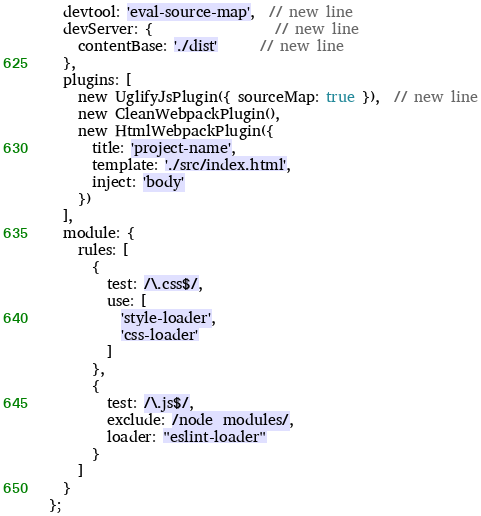<code> <loc_0><loc_0><loc_500><loc_500><_JavaScript_>  devtool: 'eval-source-map',  // new line
  devServer: {                 // new line
    contentBase: './dist'      // new line
  },
  plugins: [
    new UglifyJsPlugin({ sourceMap: true }),  // new line
    new CleanWebpackPlugin(),
    new HtmlWebpackPlugin({
      title: 'project-name',
      template: './src/index.html',
      inject: 'body'
    })
  ],
  module: {
    rules: [
      {
        test: /\.css$/,
        use: [
          'style-loader',
          'css-loader'
        ]
      },
      {
        test: /\.js$/,
        exclude: /node_modules/,
        loader: "eslint-loader"
      }
    ]
  }
};</code> 